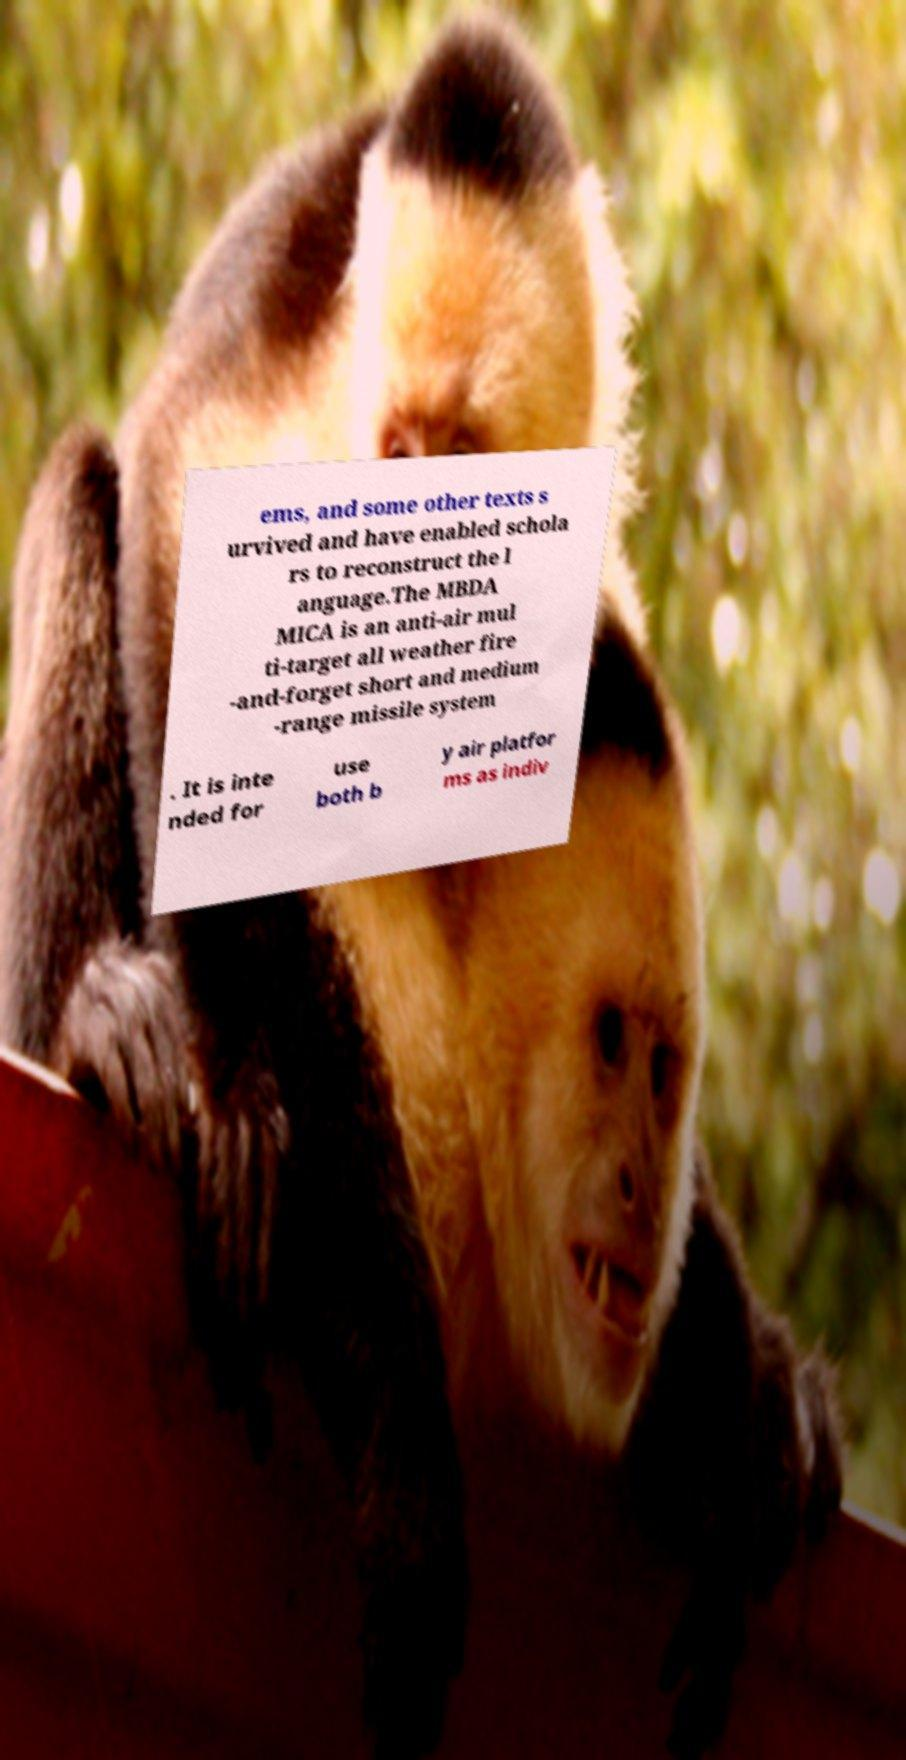Please identify and transcribe the text found in this image. ems, and some other texts s urvived and have enabled schola rs to reconstruct the l anguage.The MBDA MICA is an anti-air mul ti-target all weather fire -and-forget short and medium -range missile system . It is inte nded for use both b y air platfor ms as indiv 